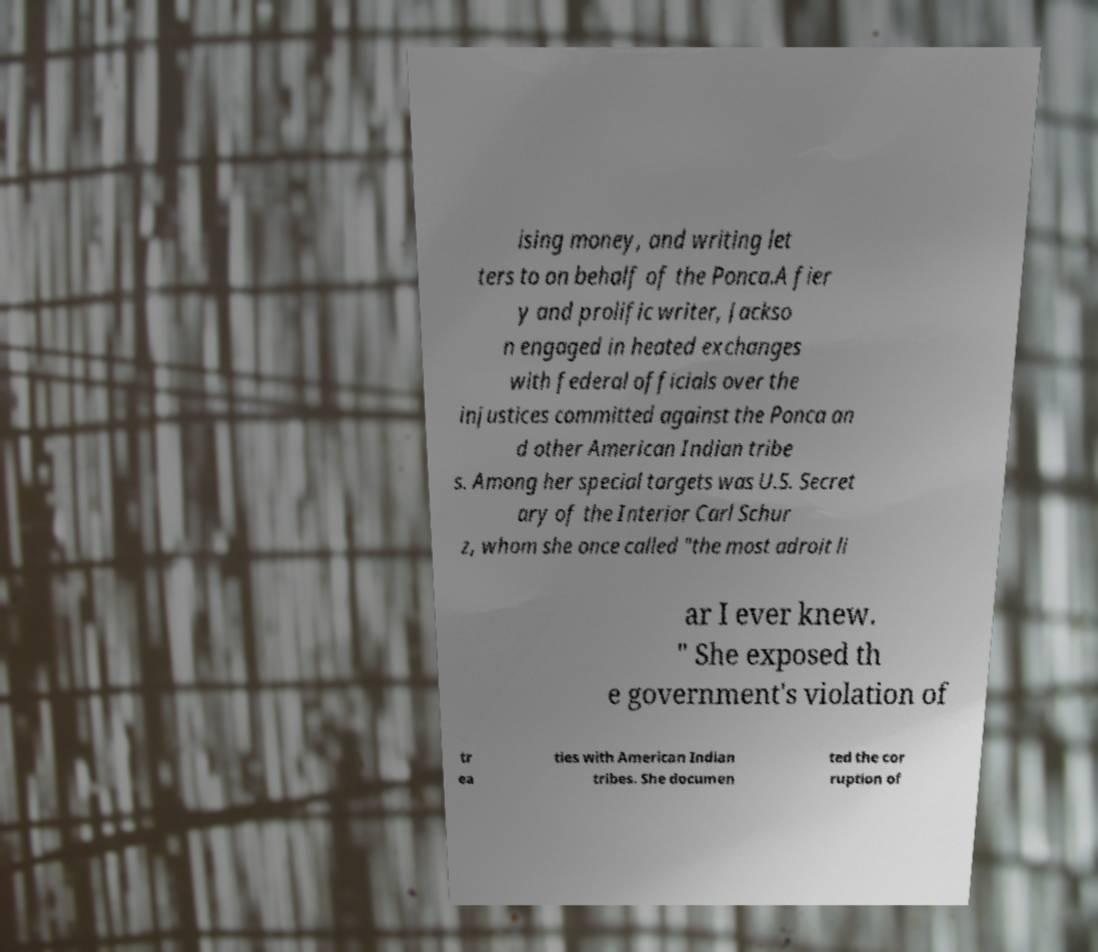Can you read and provide the text displayed in the image?This photo seems to have some interesting text. Can you extract and type it out for me? ising money, and writing let ters to on behalf of the Ponca.A fier y and prolific writer, Jackso n engaged in heated exchanges with federal officials over the injustices committed against the Ponca an d other American Indian tribe s. Among her special targets was U.S. Secret ary of the Interior Carl Schur z, whom she once called "the most adroit li ar I ever knew. " She exposed th e government's violation of tr ea ties with American Indian tribes. She documen ted the cor ruption of 